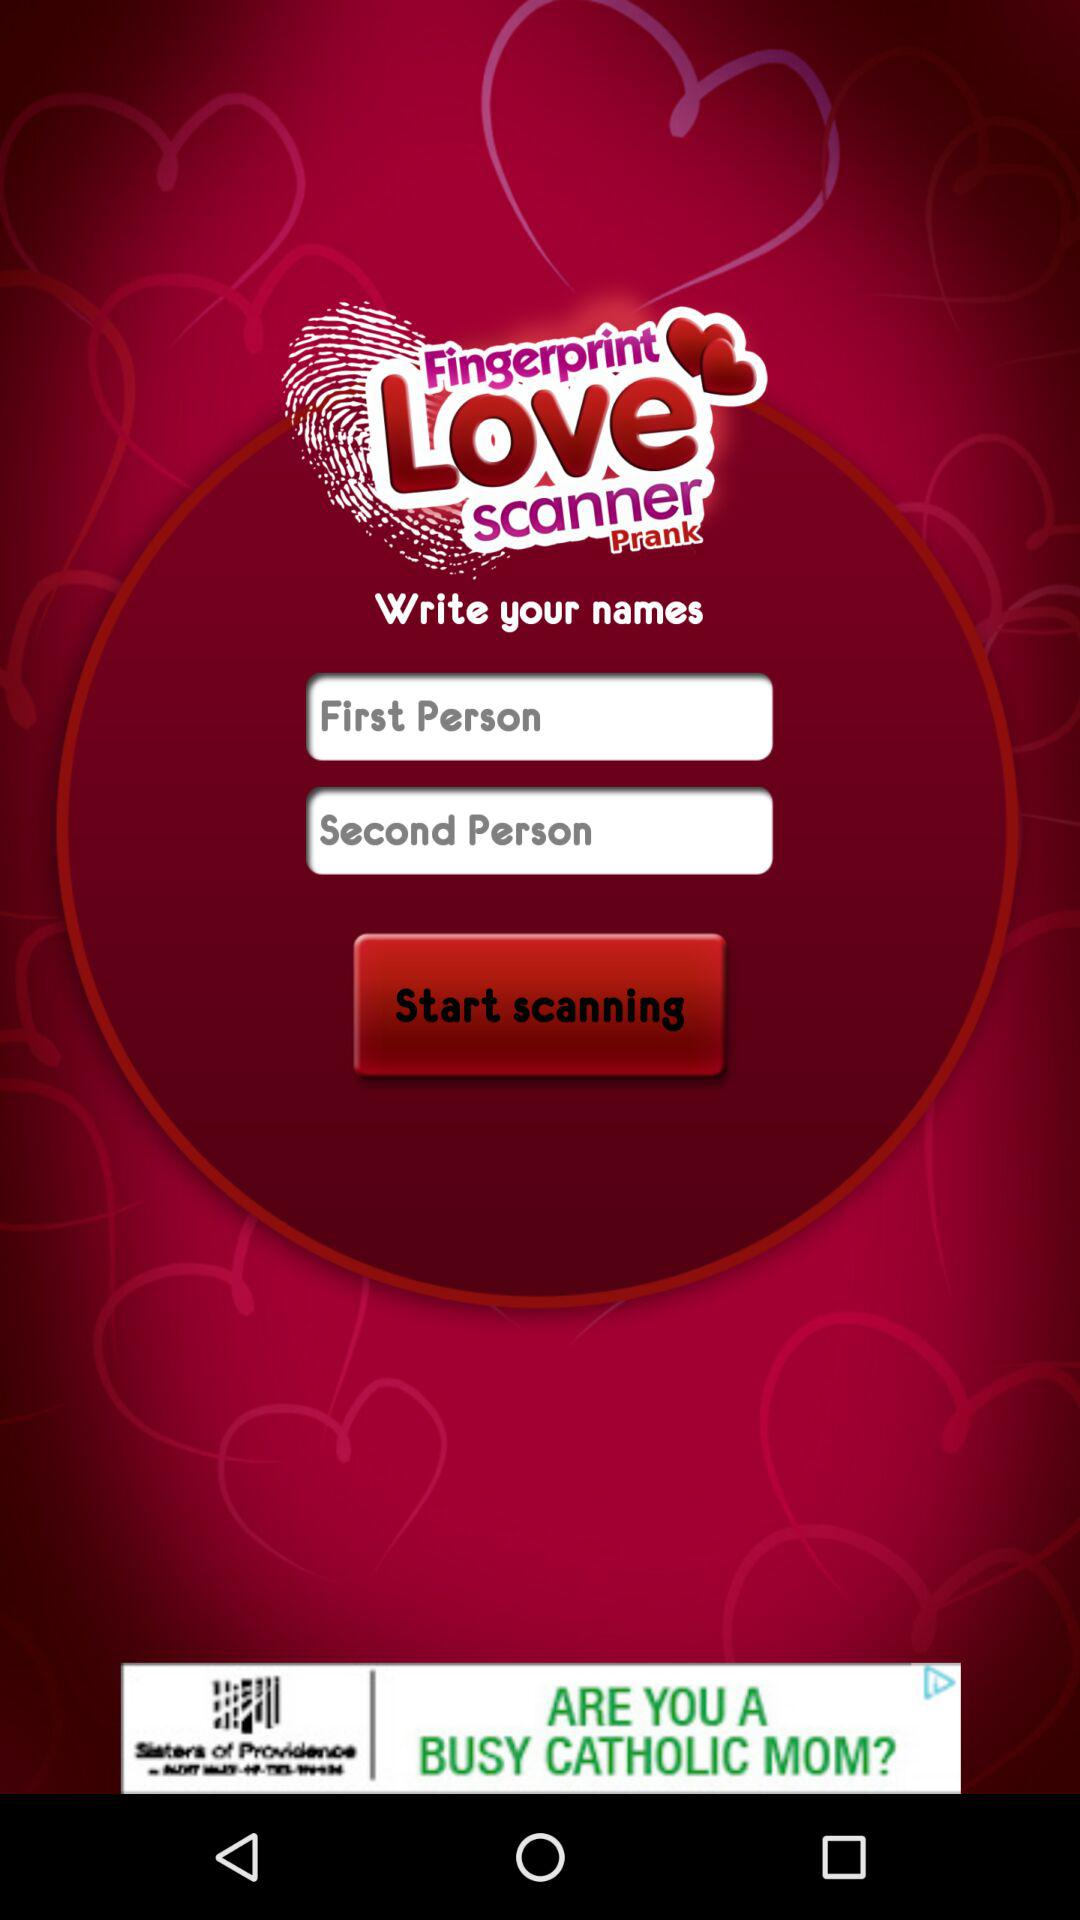What is the name of application? The name of the application is "Fingerprint Love scanner Prank". 